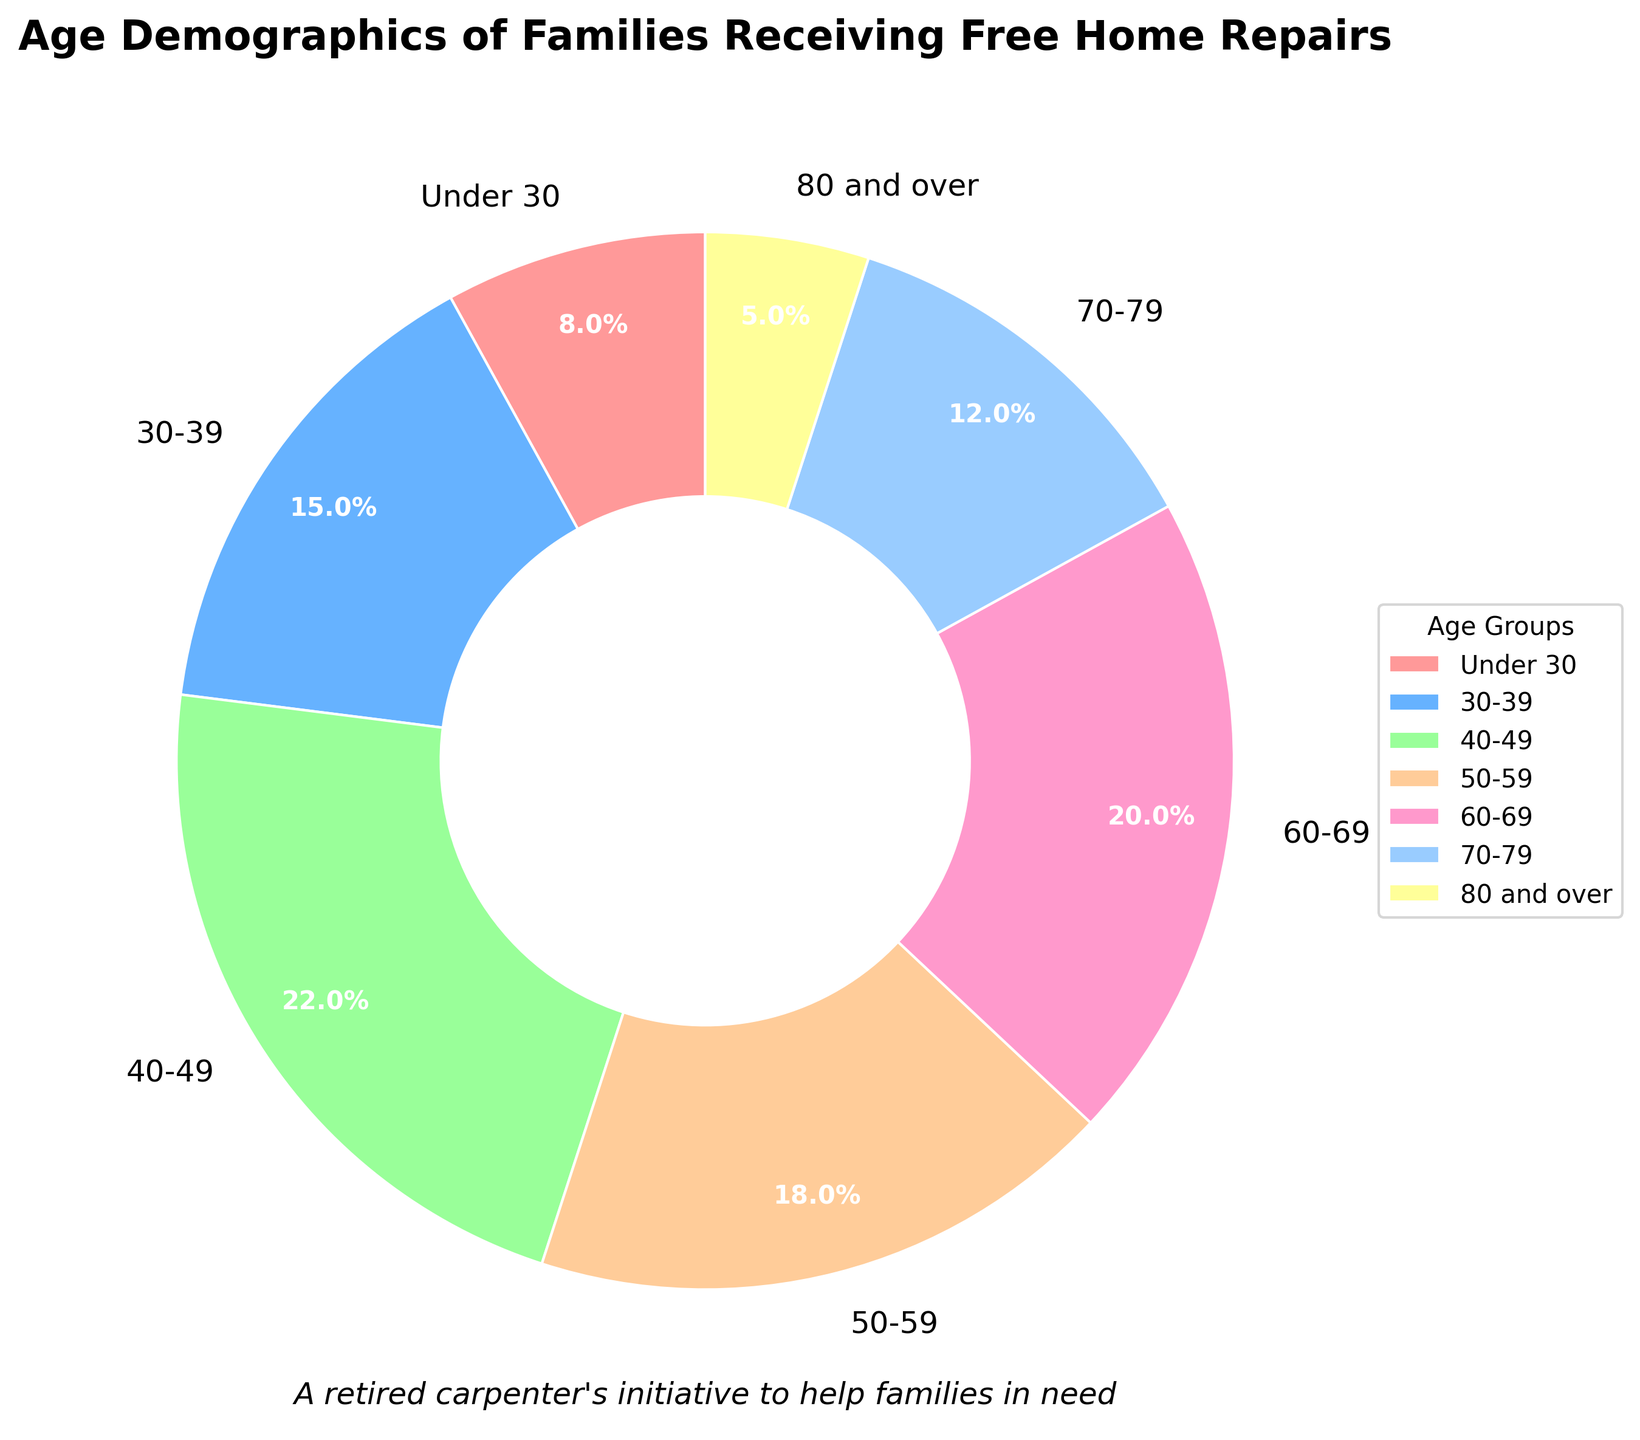What percentage of families receiving free home repairs are aged under 30? The chart explicitly shows the percentage of each age group. The segment labeled "Under 30" reveals that this group accounts for 8% of the total.
Answer: 8% Which age group has the highest representation in the pie chart? By examining the size of the pie segments, it's clear that the "40-49" group occupies the largest space, indicating the highest percentage.
Answer: 40-49 What is the combined percentage for families aged 60 and older? Add the percentages for the age groups "60-69," "70-79," and "80 and over". These are 20%, 12%, and 5%, respectively. The sum is 20% + 12% + 5% = 37%.
Answer: 37% How does the percentage of the 50-59 age group compare to the 30-39 age group? The "50-59" segment represents 18% of the chart, while the "30-39" segment represents 15%. Therefore, the "50-59" group has a higher percentage.
Answer: 50-59 has higher Which age group is represented by the wedge with a pink color? The pie chart uses specific colors for each age group. The wedge with the pink color corresponds to the "Under 30" age group.
Answer: Under 30 What is the difference in percentage between the 40-49 and 80 and over age groups? Subtract the percentage of the "80 and over" group from the "40-49" group. The "40-49" group is 22% and the "80 and over" group is 5%. The difference is 22% - 5% = 17%.
Answer: 17% Which age groups collectively represent less than 20% of the pie chart? Identify the age groups with individual percentages that sum to less than 20%. The groups "Under 30," "70-79," and "80 and over" have percentages of 8%, 12%, and 5%, respectively. They combine to make 25%, but need individual consideration. Only the "Under 30" and "80 and over" groups are each below 20%.
Answer: Under 30, 80 and over What proportion of the pie chart does the combined 40-59 age range represent? Add the percentages for the age groups "40-49" and "50-59". These are 22% and 18%, respectively. The sum is 22% + 18% = 40%.
Answer: 40% What is the percentage difference between the smallest and largest age groups? The smallest age group is "80 and over" at 5%, and the largest is "40-49" at 22%. The difference is 22% - 5% = 17%.
Answer: 17% Which age group is represented by the blue-colored wedge? The pie chart shows color-coded wedges, where the blue wedge corresponds to the "30-39" age group.
Answer: 30-39 